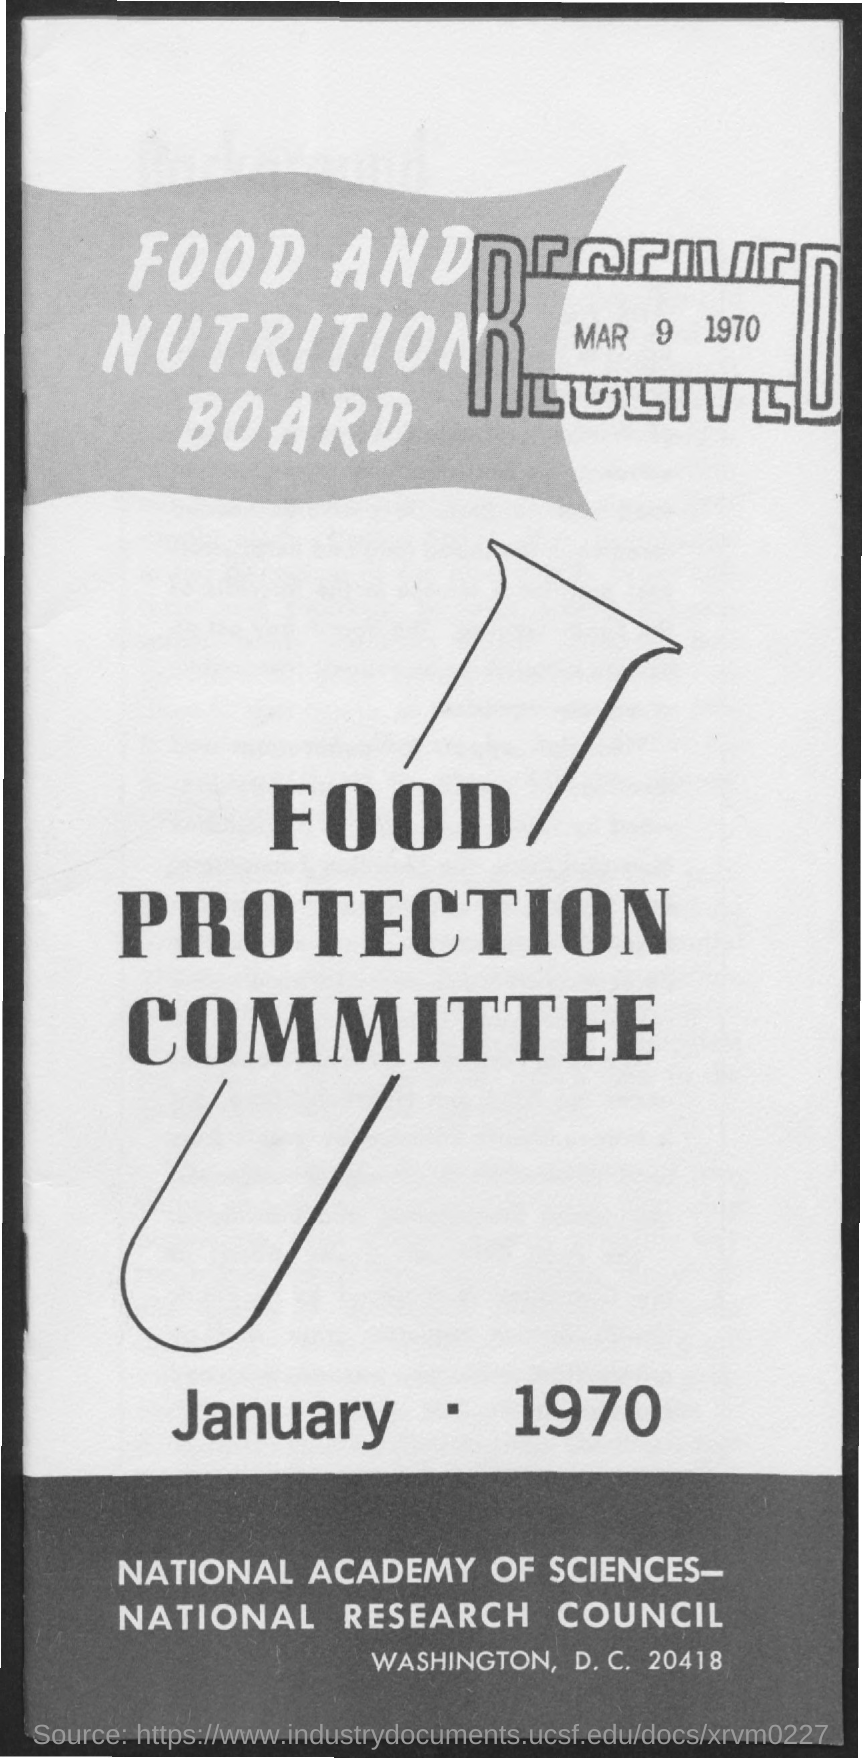List a handful of essential elements in this visual. The received date is March 9, 1970. 